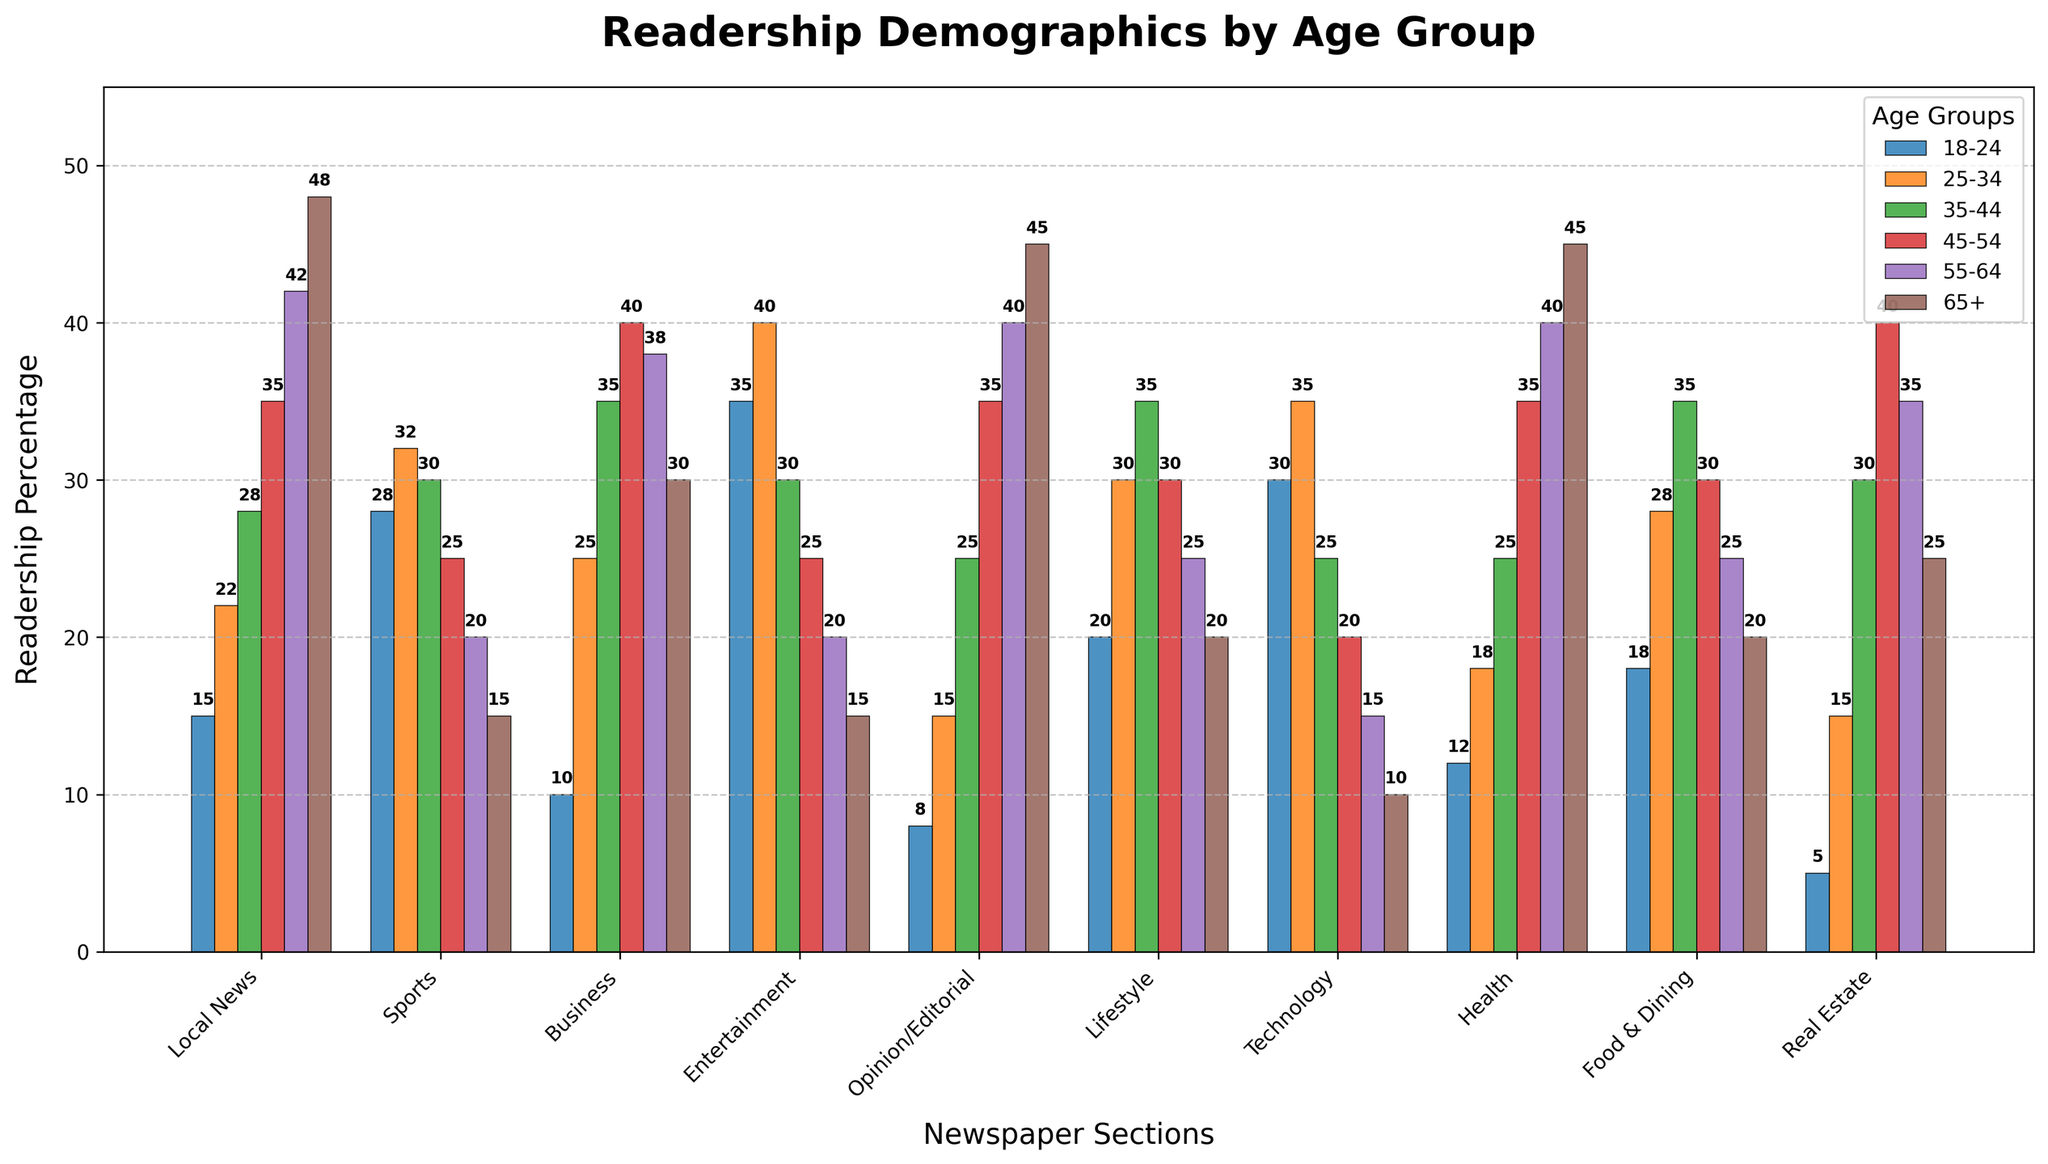What age group reads the Local News the most? First, locate the Local News section on the x-axis. Then, find the tallest bar within that section, which indicates the highest readership percentage. This bar corresponds to the age group of 65+.
Answer: 65+ Which section has the highest readership among the 25-34 age group? Identify the bars associated with the 25-34 age group (colored differently and labeled). Then, look for the tallest bar among these, which belongs to the Entertainment section.
Answer: Entertainment What is the average readership percentage for the 45-54 age group across all sections? Extract the values for the 45-54 age group from each section: 35, 25, 40, 25, 35, 30, 20, 35, 30, 40. Sum these values to get 315. There are 10 sections, so the average is 315/10 = 31.5.
Answer: 31.5 Compare the readership between 18-24 and 65+ for the Technology section. Which group reads it more, and by how much? Locate the Technology section and find the bars for the 18-24 and 65+ age groups. The 18-24 readership is 30, and the 65+ readership is 10. The 18-24 age group reads it more by 30 - 10 = 20.
Answer: 18-24, by 20 Which age group has the lowest readership for the Business section? Find the Business section on the x-axis and look for the shortest bar within that group, which indicates the lowest percentage. This bar corresponds to the 18-24 age group.
Answer: 18-24 What is the sum of the readership percentages for the 55-64 age group in the Health and Food & Dining sections? Identify the readership percentages for the 55-64 age group in both sections: 40 (Health) and 25 (Food & Dining). Sum these values: 40 + 25 = 65.
Answer: 65 For the Opinion/Editorial section, which has a higher readership percentage: 35-44 or 55-64? Locate the Opinion/Editorial section and compare the heights of the bars for the 35-44 and 55-64 age groups. The 55-64 age group has a higher readership (40) compared to the 35-44 age group (25).
Answer: 55-64 What is the difference between the highest and lowest readership percentages for the Lifestyle section? For the Lifestyle section, find the highest and lowest readership percentages: highest is 35 (both 35-44 and 25-34), and the lowest is 20 (65+). The difference is 35 - 20 = 15.
Answer: 15 Which section shows the most balanced readership across all age groups (least variation in bar heights)? Inspect all sections and compare the variation in bar heights. The Business section appears to have relatively balanced readership across all age groups. Calculate deviations or observe visually for confirmation.
Answer: Business How does the readership distribution for the Food & Dining section compare visually to the Local News section? Identify the Food & Dining and Local News sections and compare the heights of the bars for each age group. The Local News section has a diverse readership with higher values skewing towards older age groups, whereas Food & Dining values are more balanced but moderately high for middle age groups.
Answer: Local News skews older, Food & Dining is more balanced 